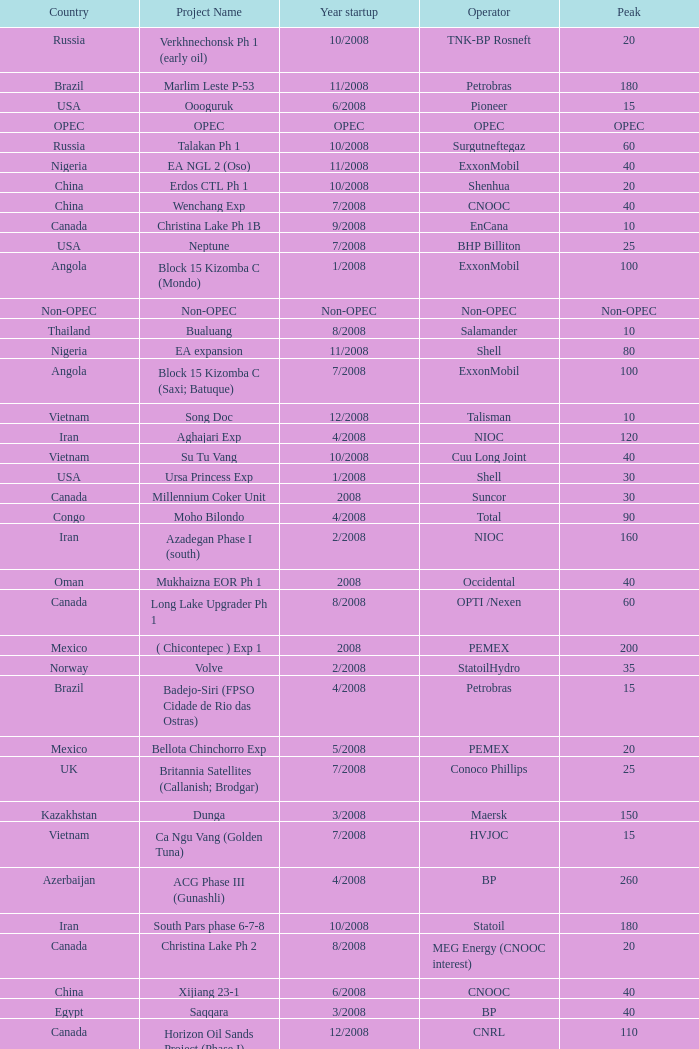What is the Operator with a Peak that is 55? PEMEX. 